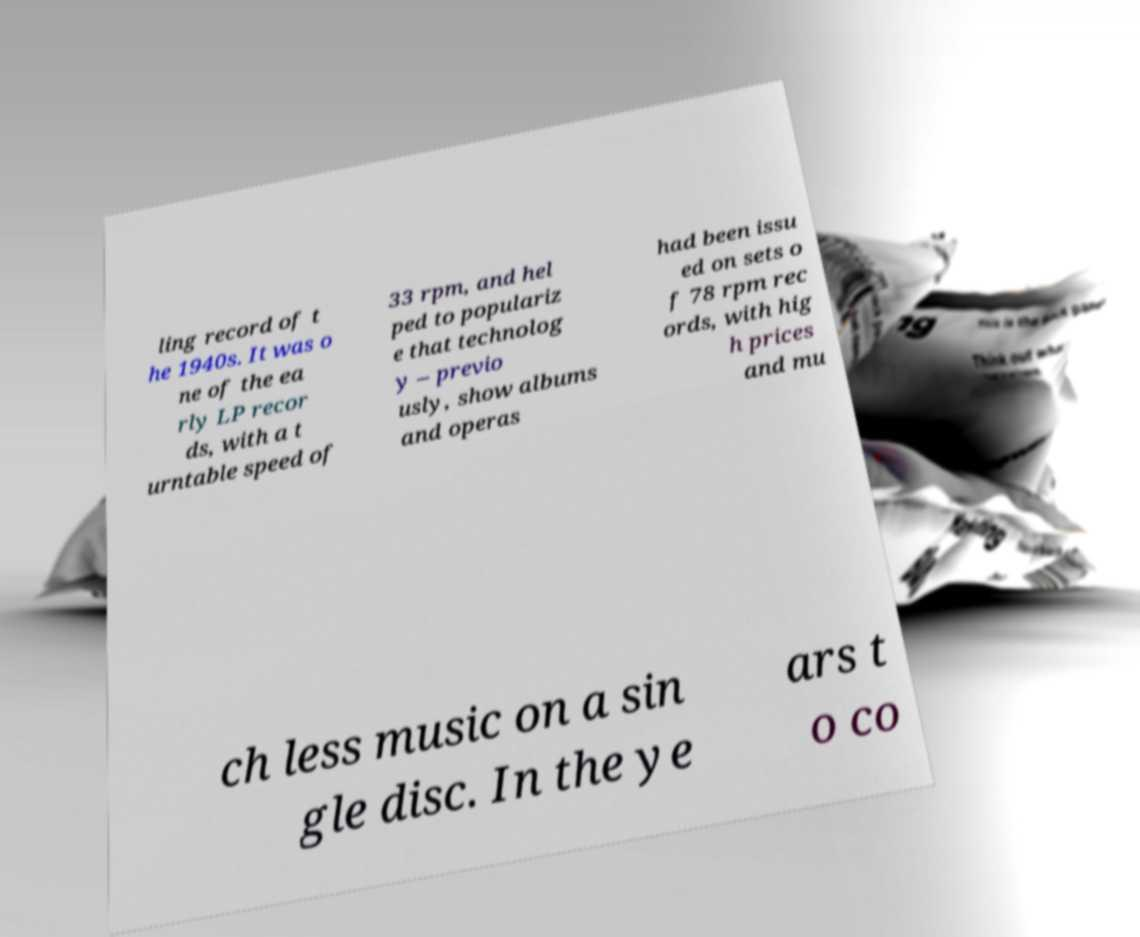Can you read and provide the text displayed in the image?This photo seems to have some interesting text. Can you extract and type it out for me? ling record of t he 1940s. It was o ne of the ea rly LP recor ds, with a t urntable speed of 33 rpm, and hel ped to populariz e that technolog y – previo usly, show albums and operas had been issu ed on sets o f 78 rpm rec ords, with hig h prices and mu ch less music on a sin gle disc. In the ye ars t o co 